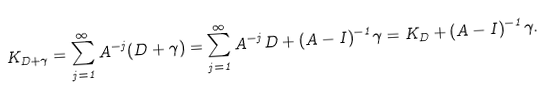Convert formula to latex. <formula><loc_0><loc_0><loc_500><loc_500>K _ { D + \gamma } = \sum _ { j = 1 } ^ { \infty } A ^ { - j } ( D + \gamma ) = \sum _ { j = 1 } ^ { \infty } A ^ { - j } D + ( A - I ) ^ { - 1 } \gamma = K _ { D } + ( A - I ) ^ { - 1 } \gamma .</formula> 